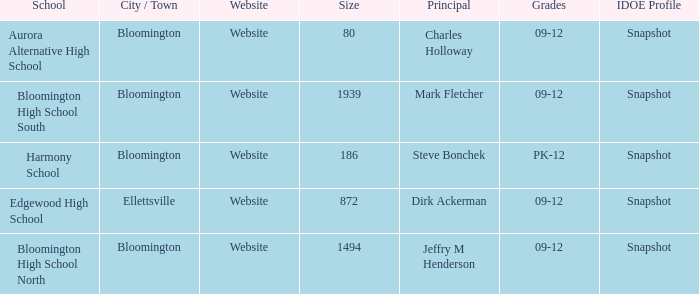How many websites are there for the school with 1939 students? 1.0. 